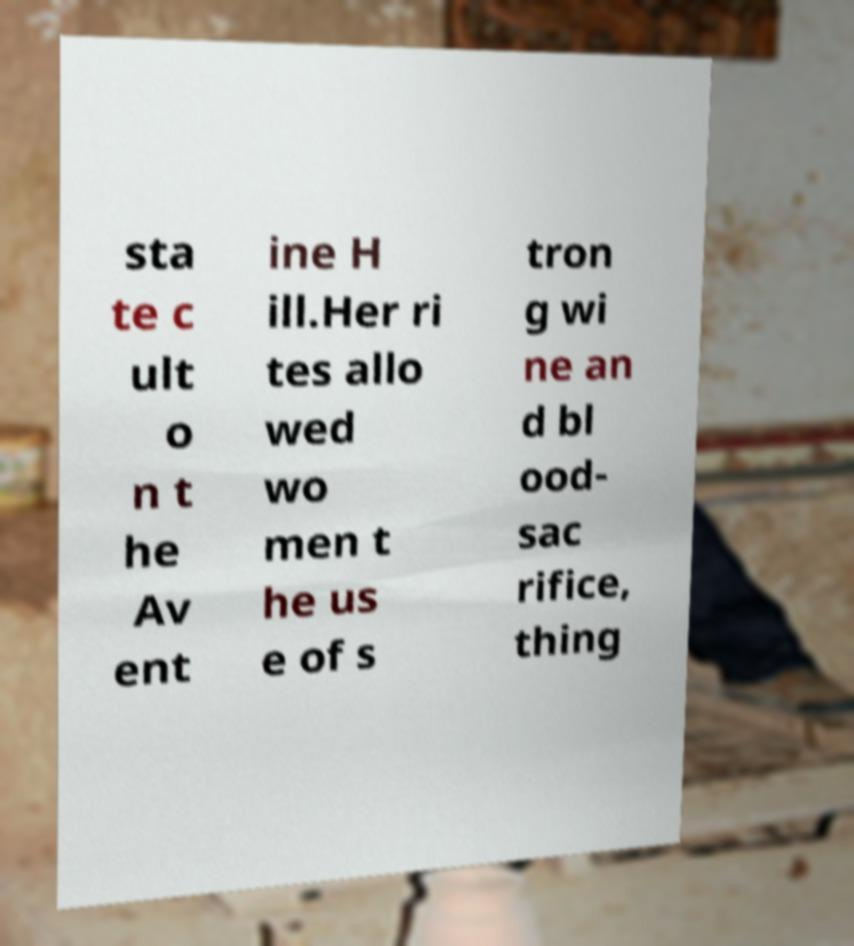There's text embedded in this image that I need extracted. Can you transcribe it verbatim? sta te c ult o n t he Av ent ine H ill.Her ri tes allo wed wo men t he us e of s tron g wi ne an d bl ood- sac rifice, thing 